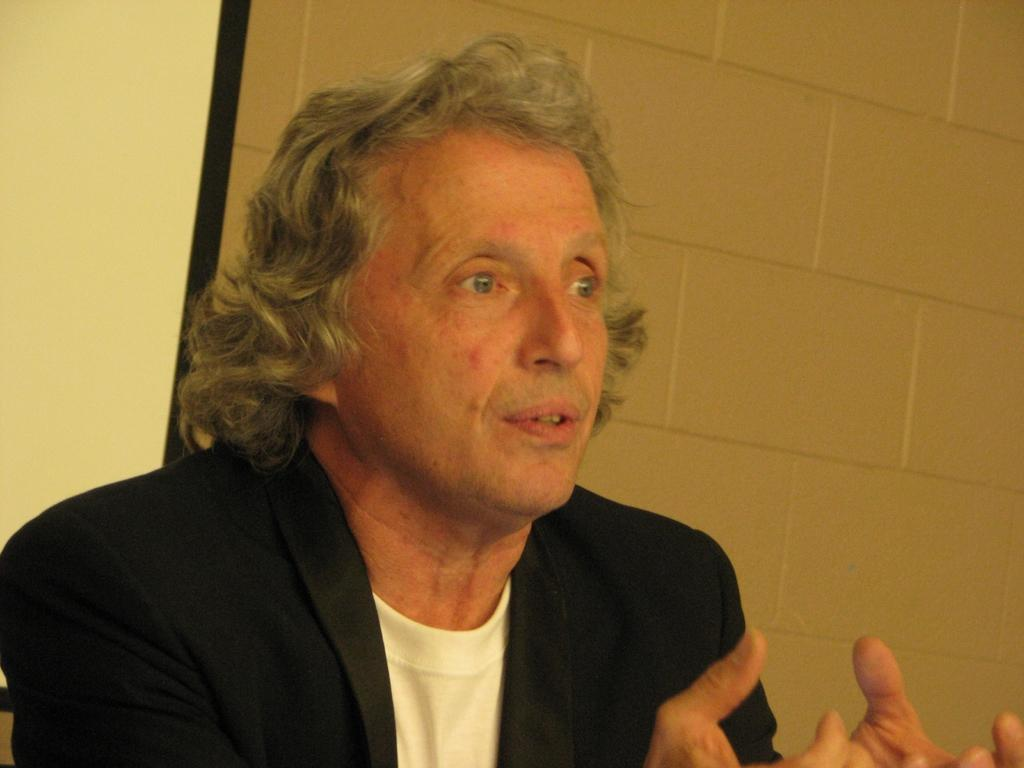Who is present in the image? There is a man in the image. What is the man wearing in the image? The man is wearing a black coat. What can be seen in the background of the image? There is a wall visible in the background of the image. How many frogs are sitting on the clock in the image? There are no frogs or clocks present in the image. What is the current weather like in the image? The provided facts do not mention the weather, so it cannot be determined from the image. 